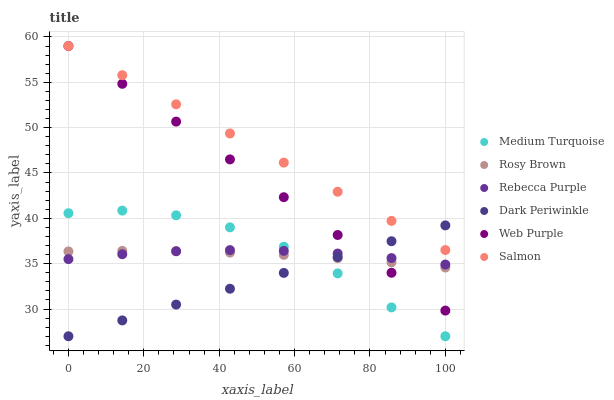Does Dark Periwinkle have the minimum area under the curve?
Answer yes or no. Yes. Does Salmon have the maximum area under the curve?
Answer yes or no. Yes. Does Web Purple have the minimum area under the curve?
Answer yes or no. No. Does Web Purple have the maximum area under the curve?
Answer yes or no. No. Is Salmon the smoothest?
Answer yes or no. Yes. Is Medium Turquoise the roughest?
Answer yes or no. Yes. Is Web Purple the smoothest?
Answer yes or no. No. Is Web Purple the roughest?
Answer yes or no. No. Does Medium Turquoise have the lowest value?
Answer yes or no. Yes. Does Web Purple have the lowest value?
Answer yes or no. No. Does Web Purple have the highest value?
Answer yes or no. Yes. Does Rebecca Purple have the highest value?
Answer yes or no. No. Is Medium Turquoise less than Salmon?
Answer yes or no. Yes. Is Salmon greater than Medium Turquoise?
Answer yes or no. Yes. Does Web Purple intersect Salmon?
Answer yes or no. Yes. Is Web Purple less than Salmon?
Answer yes or no. No. Is Web Purple greater than Salmon?
Answer yes or no. No. Does Medium Turquoise intersect Salmon?
Answer yes or no. No. 